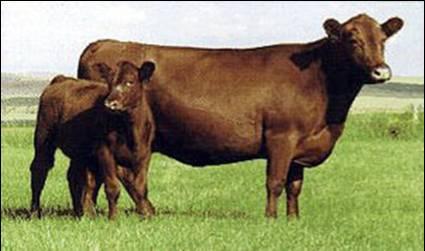What is the baby doing?
Answer briefly. Standing. How many cows are in this photo?
Answer briefly. 2. Are these cows looking at the same thing?
Quick response, please. No. Are these cows the same age?
Quick response, please. No. What color is the younger cow?
Write a very short answer. Brown. Is the grass dry?
Keep it brief. Yes. 